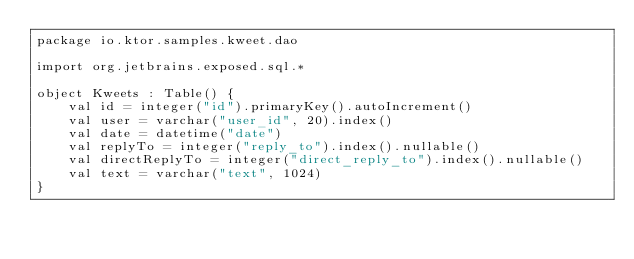<code> <loc_0><loc_0><loc_500><loc_500><_Kotlin_>package io.ktor.samples.kweet.dao

import org.jetbrains.exposed.sql.*

object Kweets : Table() {
    val id = integer("id").primaryKey().autoIncrement()
    val user = varchar("user_id", 20).index()
    val date = datetime("date")
    val replyTo = integer("reply_to").index().nullable()
    val directReplyTo = integer("direct_reply_to").index().nullable()
    val text = varchar("text", 1024)
}
</code> 